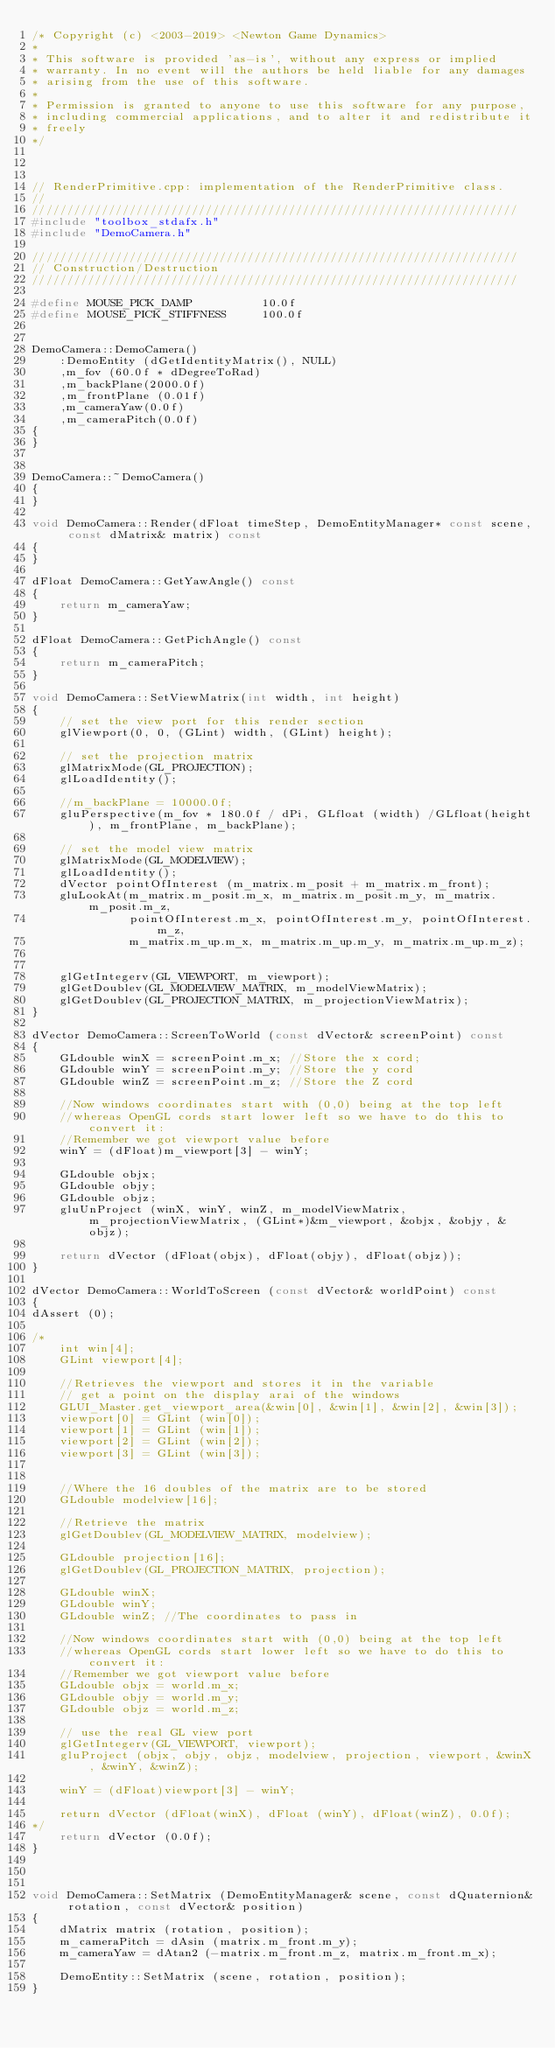Convert code to text. <code><loc_0><loc_0><loc_500><loc_500><_C++_>/* Copyright (c) <2003-2019> <Newton Game Dynamics>
* 
* This software is provided 'as-is', without any express or implied
* warranty. In no event will the authors be held liable for any damages
* arising from the use of this software.
* 
* Permission is granted to anyone to use this software for any purpose,
* including commercial applications, and to alter it and redistribute it
* freely
*/



// RenderPrimitive.cpp: implementation of the RenderPrimitive class.
//
//////////////////////////////////////////////////////////////////////
#include "toolbox_stdafx.h"
#include "DemoCamera.h"

//////////////////////////////////////////////////////////////////////
// Construction/Destruction
//////////////////////////////////////////////////////////////////////

#define MOUSE_PICK_DAMP			 10.0f
#define MOUSE_PICK_STIFFNESS	 100.0f


DemoCamera::DemoCamera()
	:DemoEntity (dGetIdentityMatrix(), NULL) 
	,m_fov (60.0f * dDegreeToRad)
	,m_backPlane(2000.0f)
	,m_frontPlane (0.01f)
	,m_cameraYaw(0.0f)
	,m_cameraPitch(0.0f)
{
}

	
DemoCamera::~DemoCamera()
{
}

void DemoCamera::Render(dFloat timeStep, DemoEntityManager* const scene, const dMatrix& matrix) const
{
}

dFloat DemoCamera::GetYawAngle() const
{
	return m_cameraYaw;
}

dFloat DemoCamera::GetPichAngle() const
{
	return m_cameraPitch;
}

void DemoCamera::SetViewMatrix(int width, int height)
{
	// set the view port for this render section
	glViewport(0, 0, (GLint) width, (GLint) height);

	// set the projection matrix
	glMatrixMode(GL_PROJECTION);
	glLoadIdentity();

	//m_backPlane = 10000.0f;
	gluPerspective(m_fov * 180.0f / dPi, GLfloat (width) /GLfloat(height), m_frontPlane, m_backPlane);

	// set the model view matrix 
	glMatrixMode(GL_MODELVIEW);
	glLoadIdentity();
	dVector pointOfInterest (m_matrix.m_posit + m_matrix.m_front);
	gluLookAt(m_matrix.m_posit.m_x, m_matrix.m_posit.m_y, m_matrix.m_posit.m_z, 
		      pointOfInterest.m_x, pointOfInterest.m_y, pointOfInterest.m_z, 
			  m_matrix.m_up.m_x, m_matrix.m_up.m_y, m_matrix.m_up.m_z);	


	glGetIntegerv(GL_VIEWPORT, m_viewport); 
	glGetDoublev(GL_MODELVIEW_MATRIX, m_modelViewMatrix); 
	glGetDoublev(GL_PROJECTION_MATRIX, m_projectionViewMatrix); 
}

dVector DemoCamera::ScreenToWorld (const dVector& screenPoint) const
{
	GLdouble winX = screenPoint.m_x; //Store the x cord;
	GLdouble winY = screenPoint.m_y; //Store the y cord
	GLdouble winZ = screenPoint.m_z; //Store the Z cord

	//Now windows coordinates start with (0,0) being at the top left 
	//whereas OpenGL cords start lower left so we have to do this to convert it: 
	//Remember we got viewport value before 
	winY = (dFloat)m_viewport[3] - winY; 

	GLdouble objx;
	GLdouble objy;
	GLdouble objz;
	gluUnProject (winX, winY, winZ, m_modelViewMatrix, m_projectionViewMatrix, (GLint*)&m_viewport, &objx, &objy, &objz);

	return dVector (dFloat(objx), dFloat(objy), dFloat(objz));
}

dVector DemoCamera::WorldToScreen (const dVector& worldPoint) const
{
dAssert (0);

/*
	int win[4]; 
	GLint viewport[4]; 

	//Retrieves the viewport and stores it in the variable
	// get a point on the display arai of the windows
	GLUI_Master.get_viewport_area(&win[0], &win[1], &win[2], &win[3]);
	viewport[0] = GLint (win[0]);
	viewport[1] = GLint (win[1]);
	viewport[2] = GLint (win[2]);
	viewport[3] = GLint (win[3]);


	//Where the 16 doubles of the matrix are to be stored
	GLdouble modelview[16]; 

	//Retrieve the matrix
	glGetDoublev(GL_MODELVIEW_MATRIX, modelview); 

	GLdouble projection[16]; 
	glGetDoublev(GL_PROJECTION_MATRIX, projection);

	GLdouble winX;
	GLdouble winY;
	GLdouble winZ; //The coordinates to pass in

	//Now windows coordinates start with (0,0) being at the top left 
	//whereas OpenGL cords start lower left so we have to do this to convert it: 
	//Remember we got viewport value before 
	GLdouble objx = world.m_x;
	GLdouble objy = world.m_y;
	GLdouble objz = world.m_z;

	// use the real GL view port
	glGetIntegerv(GL_VIEWPORT, viewport); 
	gluProject (objx, objy, objz, modelview, projection, viewport, &winX, &winY, &winZ);

	winY = (dFloat)viewport[3] - winY; 

	return dVector (dFloat(winX), dFloat (winY), dFloat(winZ), 0.0f);
*/
	return dVector (0.0f);
}



void DemoCamera::SetMatrix (DemoEntityManager& scene, const dQuaternion& rotation, const dVector& position)
{
	dMatrix matrix (rotation, position);
	m_cameraPitch = dAsin (matrix.m_front.m_y);
	m_cameraYaw = dAtan2 (-matrix.m_front.m_z, matrix.m_front.m_x);

	DemoEntity::SetMatrix (scene, rotation, position);
}



</code> 